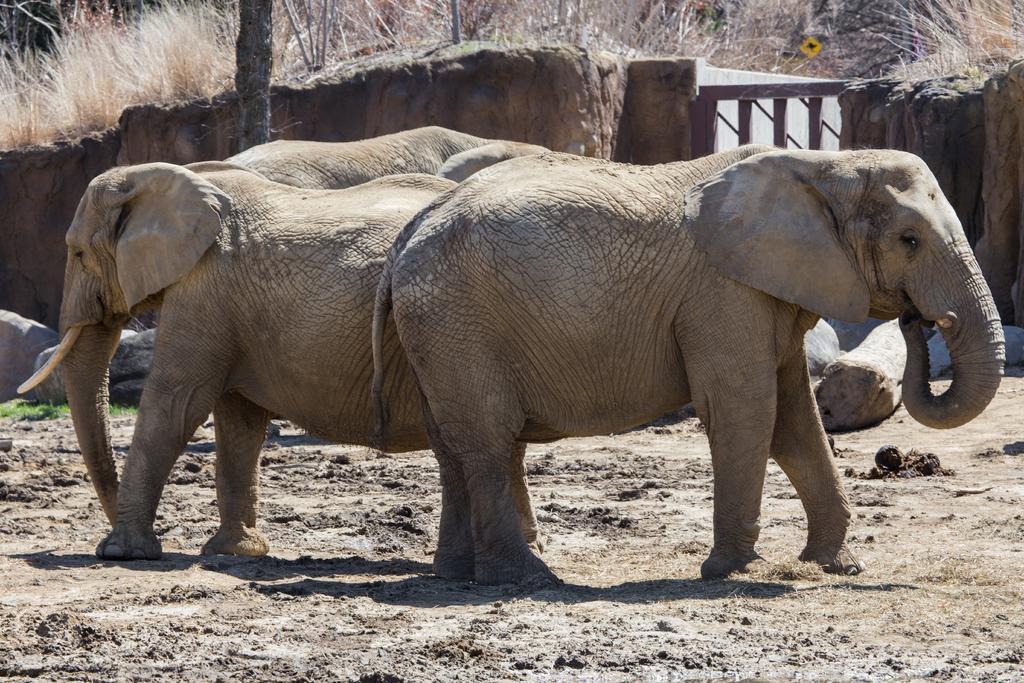How would you summarize this image in a sentence or two? This image is taken outdoors. At the bottom of the image there is a ground. In the background there are a few rocks. There is a gate. There is grass and there are a few plants on the ground. There is a tree. There are a few stones on the ground. In the middle of the image there are a few elephants. 